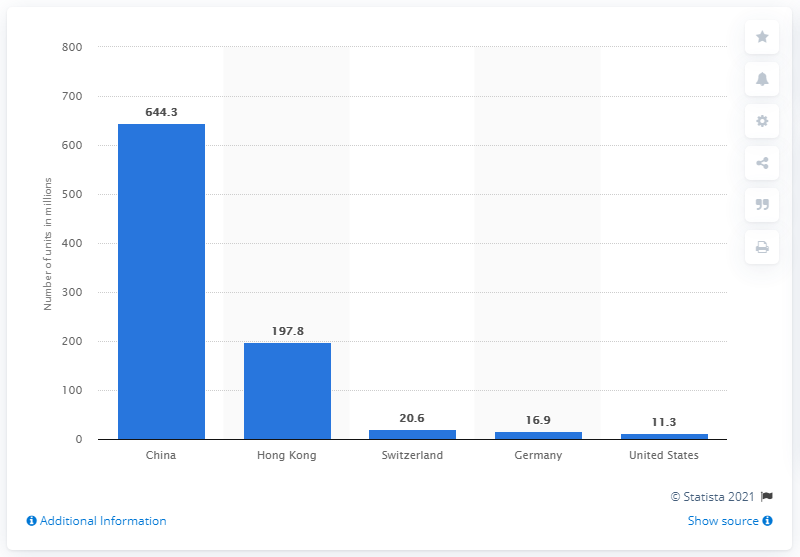Draw attention to some important aspects in this diagram. In 2019, Hong Kong exported a total of 197,800 watches. Hong Kong was the leading exporter of watches in 2019, making it the top country in the world in terms of watch exports. In 2019, China exported a total of 644.3 watches. The country that was the leading exporter of wrist watches was China. 